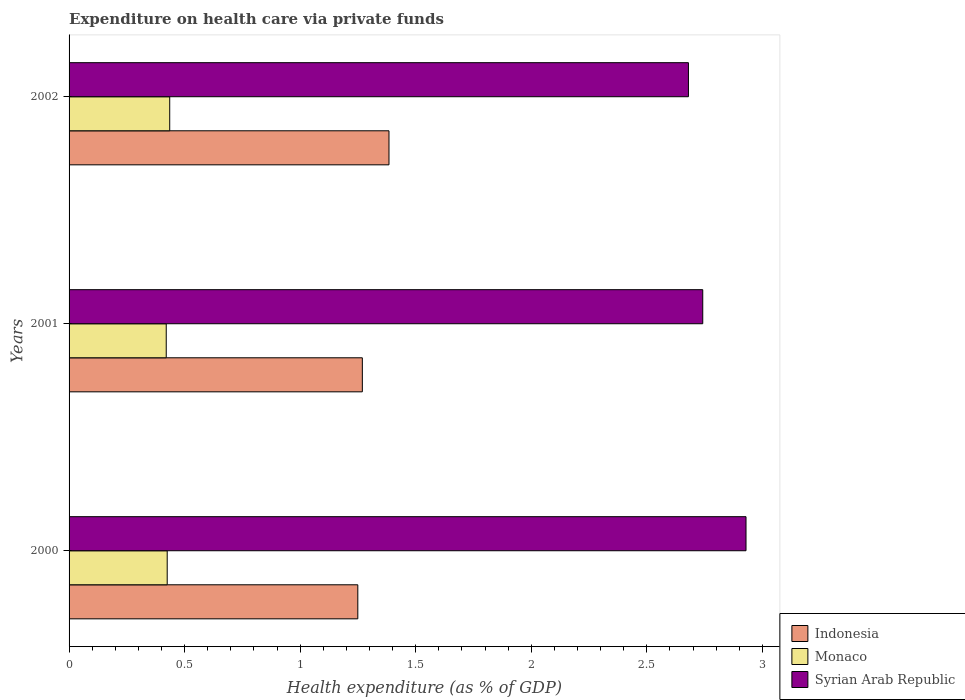How many different coloured bars are there?
Keep it short and to the point. 3. Are the number of bars per tick equal to the number of legend labels?
Provide a succinct answer. Yes. How many bars are there on the 2nd tick from the top?
Offer a very short reply. 3. What is the label of the 2nd group of bars from the top?
Make the answer very short. 2001. What is the expenditure made on health care in Syrian Arab Republic in 2000?
Your answer should be compact. 2.93. Across all years, what is the maximum expenditure made on health care in Indonesia?
Provide a succinct answer. 1.38. Across all years, what is the minimum expenditure made on health care in Monaco?
Make the answer very short. 0.42. In which year was the expenditure made on health care in Syrian Arab Republic maximum?
Your answer should be very brief. 2000. What is the total expenditure made on health care in Monaco in the graph?
Give a very brief answer. 1.28. What is the difference between the expenditure made on health care in Monaco in 2000 and that in 2001?
Ensure brevity in your answer.  0. What is the difference between the expenditure made on health care in Indonesia in 2000 and the expenditure made on health care in Monaco in 2001?
Offer a terse response. 0.83. What is the average expenditure made on health care in Indonesia per year?
Your answer should be very brief. 1.3. In the year 2002, what is the difference between the expenditure made on health care in Indonesia and expenditure made on health care in Monaco?
Your answer should be very brief. 0.95. What is the ratio of the expenditure made on health care in Indonesia in 2000 to that in 2002?
Provide a succinct answer. 0.9. Is the difference between the expenditure made on health care in Indonesia in 2000 and 2002 greater than the difference between the expenditure made on health care in Monaco in 2000 and 2002?
Your response must be concise. No. What is the difference between the highest and the second highest expenditure made on health care in Syrian Arab Republic?
Your response must be concise. 0.19. What is the difference between the highest and the lowest expenditure made on health care in Indonesia?
Give a very brief answer. 0.13. In how many years, is the expenditure made on health care in Monaco greater than the average expenditure made on health care in Monaco taken over all years?
Make the answer very short. 1. Is the sum of the expenditure made on health care in Monaco in 2000 and 2001 greater than the maximum expenditure made on health care in Syrian Arab Republic across all years?
Make the answer very short. No. What does the 2nd bar from the top in 2001 represents?
Your answer should be very brief. Monaco. What does the 3rd bar from the bottom in 2002 represents?
Ensure brevity in your answer.  Syrian Arab Republic. Are all the bars in the graph horizontal?
Offer a very short reply. Yes. What is the difference between two consecutive major ticks on the X-axis?
Give a very brief answer. 0.5. Does the graph contain any zero values?
Ensure brevity in your answer.  No. Does the graph contain grids?
Provide a succinct answer. No. Where does the legend appear in the graph?
Keep it short and to the point. Bottom right. How are the legend labels stacked?
Provide a succinct answer. Vertical. What is the title of the graph?
Keep it short and to the point. Expenditure on health care via private funds. Does "San Marino" appear as one of the legend labels in the graph?
Ensure brevity in your answer.  No. What is the label or title of the X-axis?
Offer a terse response. Health expenditure (as % of GDP). What is the Health expenditure (as % of GDP) of Indonesia in 2000?
Keep it short and to the point. 1.25. What is the Health expenditure (as % of GDP) of Monaco in 2000?
Your response must be concise. 0.42. What is the Health expenditure (as % of GDP) of Syrian Arab Republic in 2000?
Your answer should be very brief. 2.93. What is the Health expenditure (as % of GDP) of Indonesia in 2001?
Your answer should be very brief. 1.27. What is the Health expenditure (as % of GDP) of Monaco in 2001?
Ensure brevity in your answer.  0.42. What is the Health expenditure (as % of GDP) in Syrian Arab Republic in 2001?
Your answer should be very brief. 2.74. What is the Health expenditure (as % of GDP) in Indonesia in 2002?
Make the answer very short. 1.38. What is the Health expenditure (as % of GDP) of Monaco in 2002?
Offer a very short reply. 0.44. What is the Health expenditure (as % of GDP) of Syrian Arab Republic in 2002?
Provide a succinct answer. 2.68. Across all years, what is the maximum Health expenditure (as % of GDP) of Indonesia?
Provide a succinct answer. 1.38. Across all years, what is the maximum Health expenditure (as % of GDP) in Monaco?
Offer a very short reply. 0.44. Across all years, what is the maximum Health expenditure (as % of GDP) in Syrian Arab Republic?
Make the answer very short. 2.93. Across all years, what is the minimum Health expenditure (as % of GDP) of Indonesia?
Keep it short and to the point. 1.25. Across all years, what is the minimum Health expenditure (as % of GDP) of Monaco?
Give a very brief answer. 0.42. Across all years, what is the minimum Health expenditure (as % of GDP) of Syrian Arab Republic?
Offer a terse response. 2.68. What is the total Health expenditure (as % of GDP) of Indonesia in the graph?
Your answer should be very brief. 3.9. What is the total Health expenditure (as % of GDP) of Monaco in the graph?
Provide a short and direct response. 1.28. What is the total Health expenditure (as % of GDP) in Syrian Arab Republic in the graph?
Your answer should be very brief. 8.35. What is the difference between the Health expenditure (as % of GDP) of Indonesia in 2000 and that in 2001?
Give a very brief answer. -0.02. What is the difference between the Health expenditure (as % of GDP) of Monaco in 2000 and that in 2001?
Provide a short and direct response. 0. What is the difference between the Health expenditure (as % of GDP) of Syrian Arab Republic in 2000 and that in 2001?
Your answer should be very brief. 0.19. What is the difference between the Health expenditure (as % of GDP) of Indonesia in 2000 and that in 2002?
Make the answer very short. -0.13. What is the difference between the Health expenditure (as % of GDP) of Monaco in 2000 and that in 2002?
Offer a very short reply. -0.01. What is the difference between the Health expenditure (as % of GDP) of Syrian Arab Republic in 2000 and that in 2002?
Your answer should be very brief. 0.25. What is the difference between the Health expenditure (as % of GDP) in Indonesia in 2001 and that in 2002?
Ensure brevity in your answer.  -0.12. What is the difference between the Health expenditure (as % of GDP) of Monaco in 2001 and that in 2002?
Offer a terse response. -0.01. What is the difference between the Health expenditure (as % of GDP) of Syrian Arab Republic in 2001 and that in 2002?
Provide a succinct answer. 0.06. What is the difference between the Health expenditure (as % of GDP) of Indonesia in 2000 and the Health expenditure (as % of GDP) of Monaco in 2001?
Offer a terse response. 0.83. What is the difference between the Health expenditure (as % of GDP) in Indonesia in 2000 and the Health expenditure (as % of GDP) in Syrian Arab Republic in 2001?
Ensure brevity in your answer.  -1.49. What is the difference between the Health expenditure (as % of GDP) in Monaco in 2000 and the Health expenditure (as % of GDP) in Syrian Arab Republic in 2001?
Your answer should be compact. -2.32. What is the difference between the Health expenditure (as % of GDP) of Indonesia in 2000 and the Health expenditure (as % of GDP) of Monaco in 2002?
Provide a short and direct response. 0.81. What is the difference between the Health expenditure (as % of GDP) in Indonesia in 2000 and the Health expenditure (as % of GDP) in Syrian Arab Republic in 2002?
Your answer should be very brief. -1.43. What is the difference between the Health expenditure (as % of GDP) in Monaco in 2000 and the Health expenditure (as % of GDP) in Syrian Arab Republic in 2002?
Ensure brevity in your answer.  -2.26. What is the difference between the Health expenditure (as % of GDP) in Indonesia in 2001 and the Health expenditure (as % of GDP) in Monaco in 2002?
Give a very brief answer. 0.83. What is the difference between the Health expenditure (as % of GDP) of Indonesia in 2001 and the Health expenditure (as % of GDP) of Syrian Arab Republic in 2002?
Keep it short and to the point. -1.41. What is the difference between the Health expenditure (as % of GDP) of Monaco in 2001 and the Health expenditure (as % of GDP) of Syrian Arab Republic in 2002?
Your answer should be very brief. -2.26. What is the average Health expenditure (as % of GDP) in Indonesia per year?
Your response must be concise. 1.3. What is the average Health expenditure (as % of GDP) in Monaco per year?
Offer a very short reply. 0.43. What is the average Health expenditure (as % of GDP) of Syrian Arab Republic per year?
Keep it short and to the point. 2.78. In the year 2000, what is the difference between the Health expenditure (as % of GDP) of Indonesia and Health expenditure (as % of GDP) of Monaco?
Your answer should be very brief. 0.82. In the year 2000, what is the difference between the Health expenditure (as % of GDP) in Indonesia and Health expenditure (as % of GDP) in Syrian Arab Republic?
Give a very brief answer. -1.68. In the year 2000, what is the difference between the Health expenditure (as % of GDP) in Monaco and Health expenditure (as % of GDP) in Syrian Arab Republic?
Make the answer very short. -2.5. In the year 2001, what is the difference between the Health expenditure (as % of GDP) of Indonesia and Health expenditure (as % of GDP) of Monaco?
Offer a terse response. 0.85. In the year 2001, what is the difference between the Health expenditure (as % of GDP) in Indonesia and Health expenditure (as % of GDP) in Syrian Arab Republic?
Keep it short and to the point. -1.47. In the year 2001, what is the difference between the Health expenditure (as % of GDP) in Monaco and Health expenditure (as % of GDP) in Syrian Arab Republic?
Provide a succinct answer. -2.32. In the year 2002, what is the difference between the Health expenditure (as % of GDP) of Indonesia and Health expenditure (as % of GDP) of Monaco?
Provide a short and direct response. 0.95. In the year 2002, what is the difference between the Health expenditure (as % of GDP) of Indonesia and Health expenditure (as % of GDP) of Syrian Arab Republic?
Your response must be concise. -1.3. In the year 2002, what is the difference between the Health expenditure (as % of GDP) in Monaco and Health expenditure (as % of GDP) in Syrian Arab Republic?
Give a very brief answer. -2.24. What is the ratio of the Health expenditure (as % of GDP) of Indonesia in 2000 to that in 2001?
Provide a succinct answer. 0.98. What is the ratio of the Health expenditure (as % of GDP) of Monaco in 2000 to that in 2001?
Your response must be concise. 1.01. What is the ratio of the Health expenditure (as % of GDP) in Syrian Arab Republic in 2000 to that in 2001?
Your response must be concise. 1.07. What is the ratio of the Health expenditure (as % of GDP) of Indonesia in 2000 to that in 2002?
Give a very brief answer. 0.9. What is the ratio of the Health expenditure (as % of GDP) of Syrian Arab Republic in 2000 to that in 2002?
Make the answer very short. 1.09. What is the ratio of the Health expenditure (as % of GDP) of Indonesia in 2001 to that in 2002?
Keep it short and to the point. 0.92. What is the ratio of the Health expenditure (as % of GDP) in Monaco in 2001 to that in 2002?
Ensure brevity in your answer.  0.97. What is the ratio of the Health expenditure (as % of GDP) in Syrian Arab Republic in 2001 to that in 2002?
Your answer should be compact. 1.02. What is the difference between the highest and the second highest Health expenditure (as % of GDP) in Indonesia?
Your response must be concise. 0.12. What is the difference between the highest and the second highest Health expenditure (as % of GDP) of Monaco?
Provide a succinct answer. 0.01. What is the difference between the highest and the second highest Health expenditure (as % of GDP) of Syrian Arab Republic?
Your answer should be compact. 0.19. What is the difference between the highest and the lowest Health expenditure (as % of GDP) in Indonesia?
Ensure brevity in your answer.  0.13. What is the difference between the highest and the lowest Health expenditure (as % of GDP) of Monaco?
Give a very brief answer. 0.01. What is the difference between the highest and the lowest Health expenditure (as % of GDP) of Syrian Arab Republic?
Ensure brevity in your answer.  0.25. 